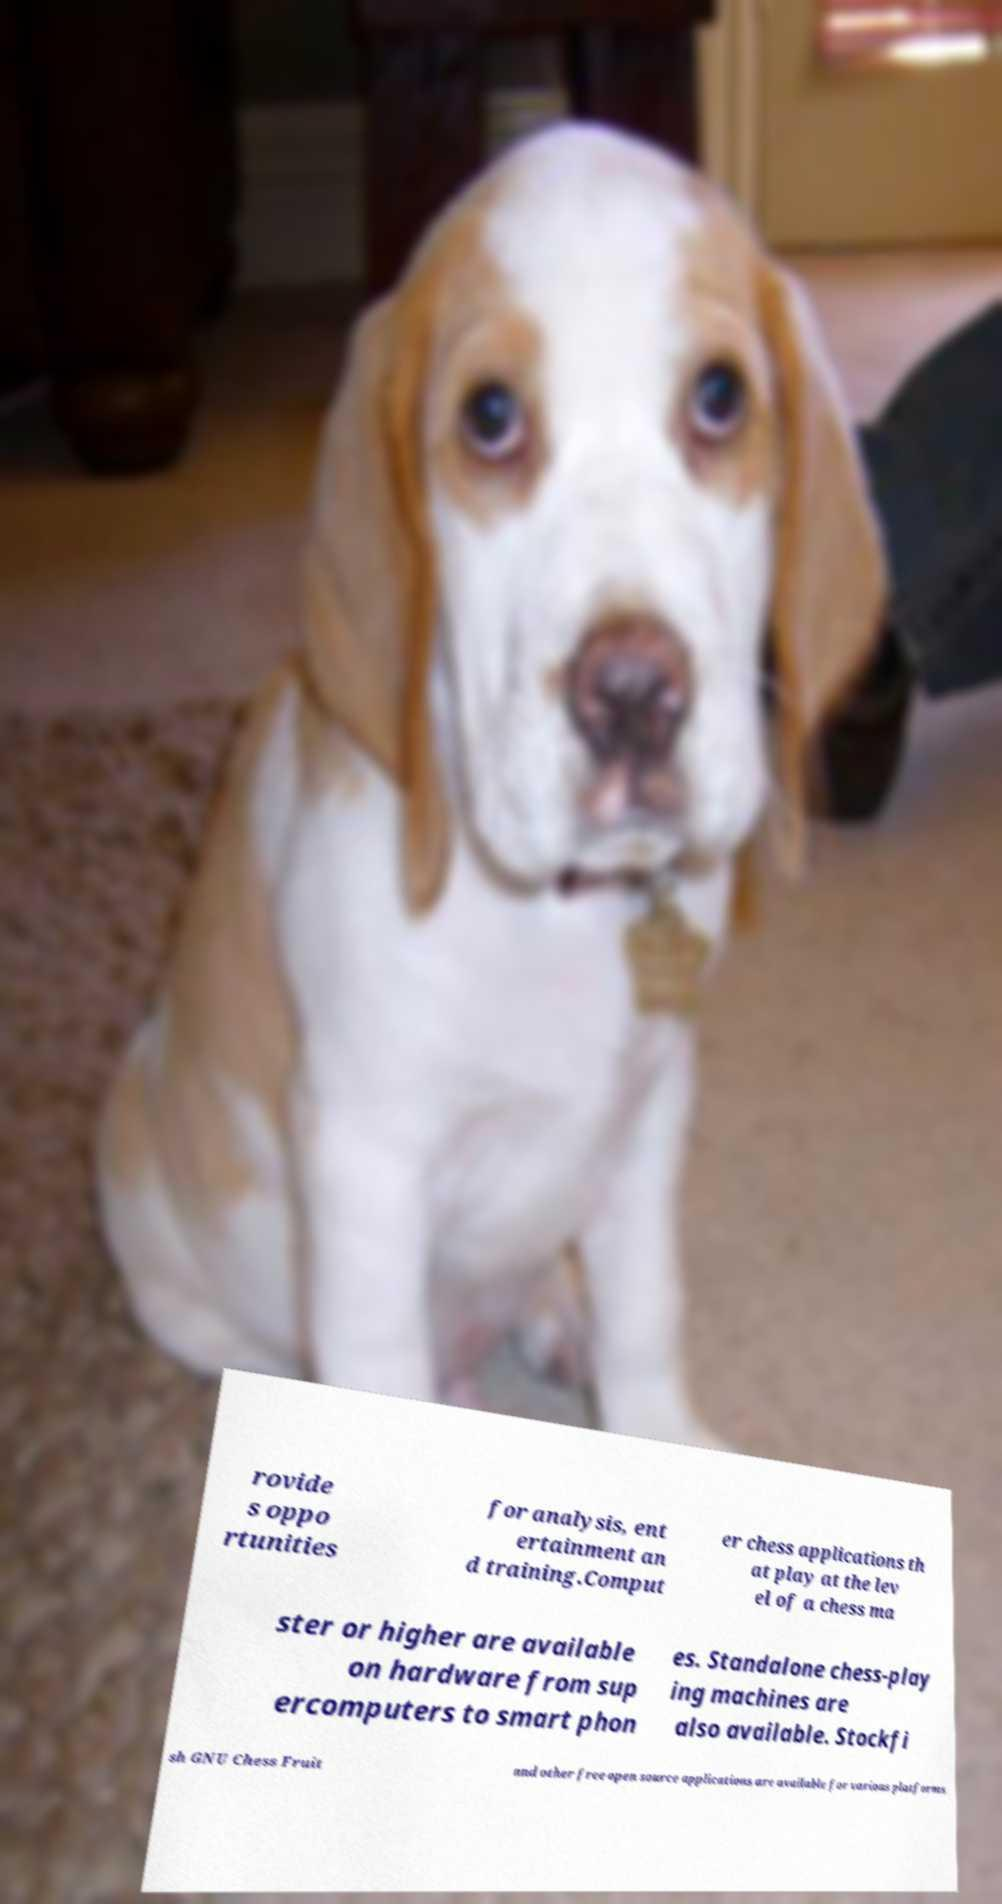Could you extract and type out the text from this image? rovide s oppo rtunities for analysis, ent ertainment an d training.Comput er chess applications th at play at the lev el of a chess ma ster or higher are available on hardware from sup ercomputers to smart phon es. Standalone chess-play ing machines are also available. Stockfi sh GNU Chess Fruit and other free open source applications are available for various platforms 